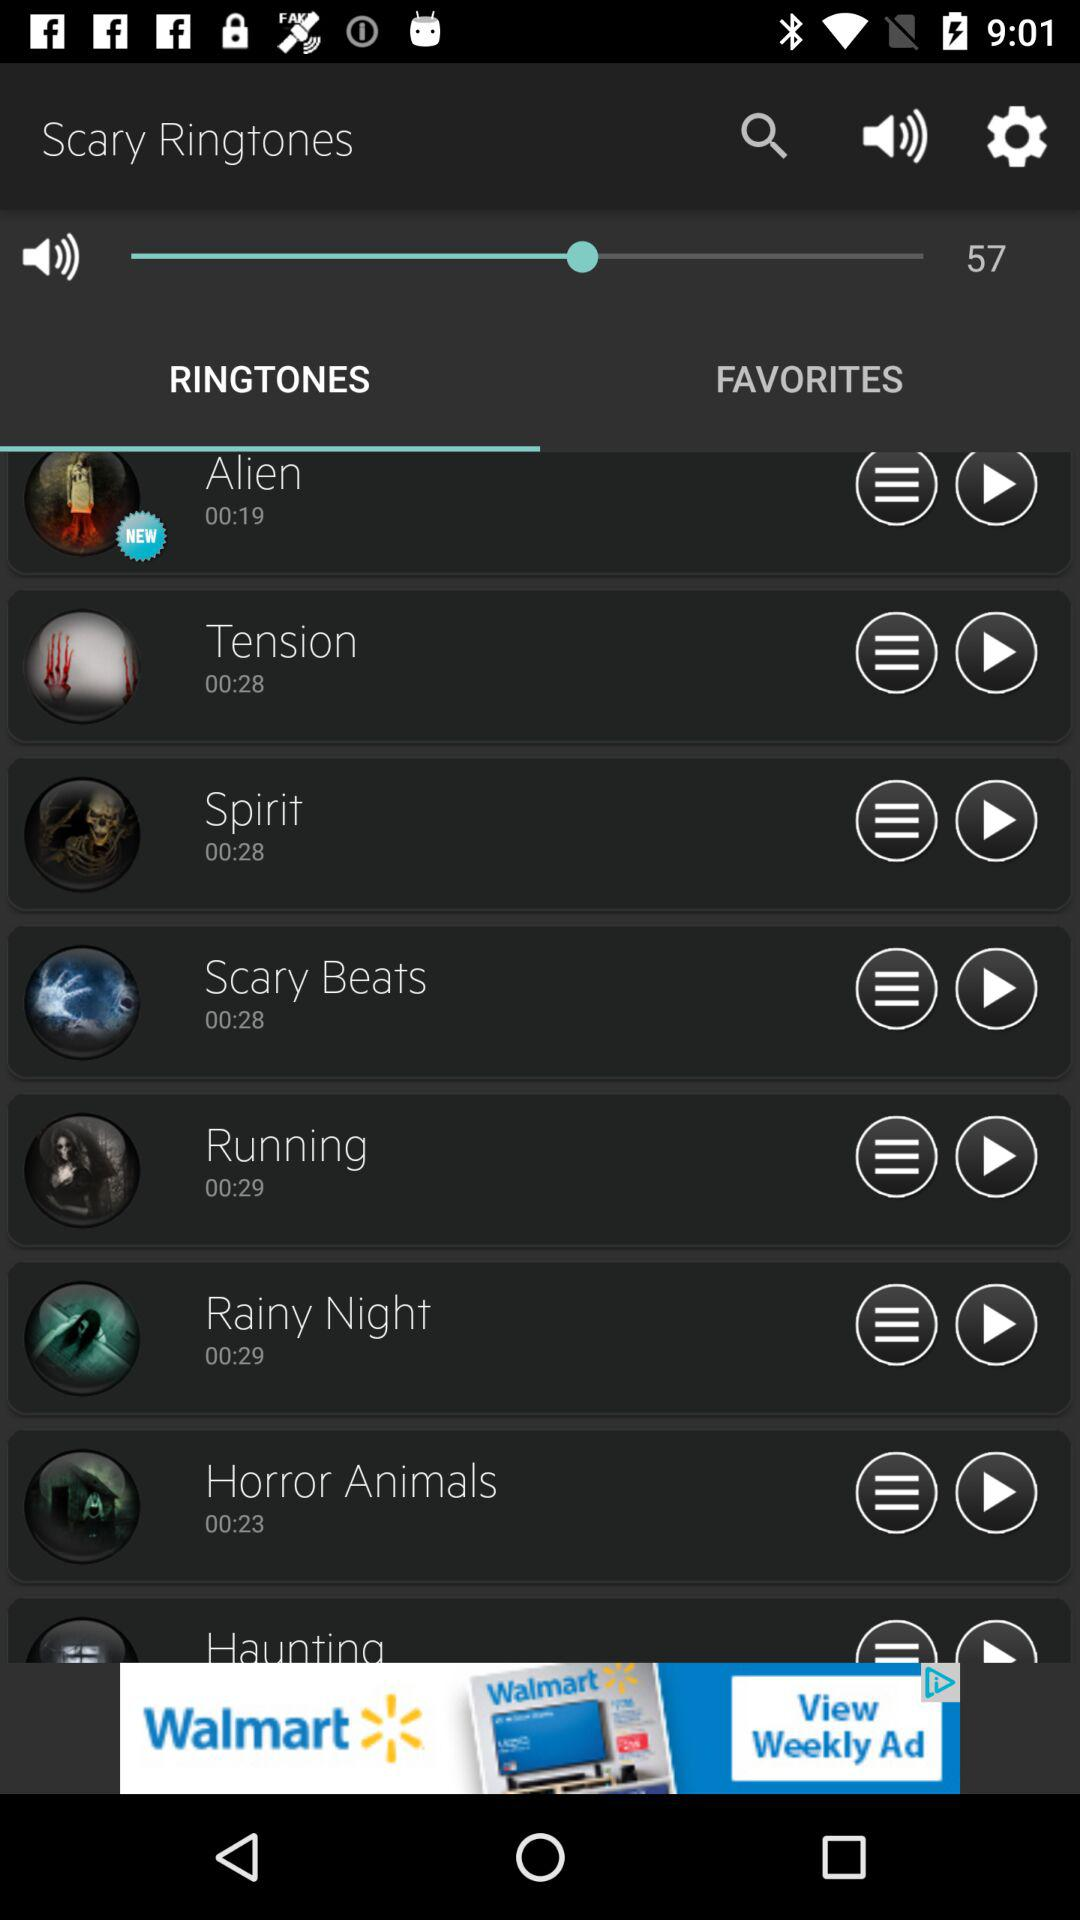What is the total duration of "Scary Beats'? The total duration is 28 seconds. 